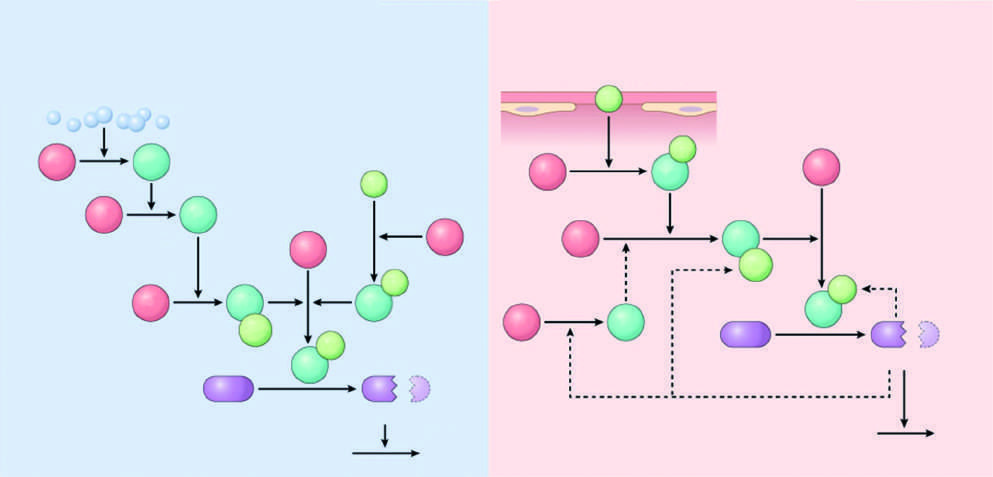what is tissue factor, in vivo?
Answer the question using a single word or phrase. The major initiator of coagulation 